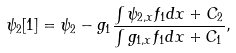<formula> <loc_0><loc_0><loc_500><loc_500>\psi _ { 2 } [ 1 ] = \psi _ { 2 } - g _ { 1 } \frac { \int \psi _ { 2 , x } f _ { 1 } { d } x + C _ { 2 } } { \int g _ { 1 , x } f _ { 1 } { d } x + C _ { 1 } } ,</formula> 